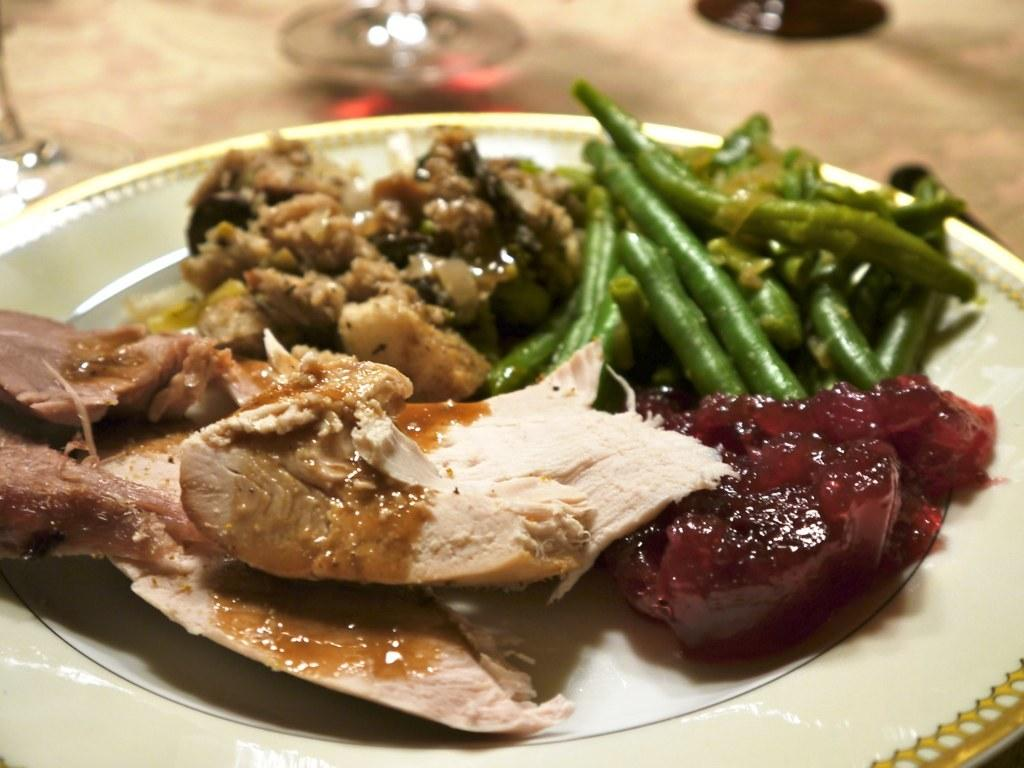What object is present on the plate in the image? There are food items on the plate in the image. What color is the plate? The plate is white in color. What other object is visible in the image besides the plate? There is a glass in the image. Can you describe the background of the image? The background of the image is blurred. What type of fish can be seen swimming in the jail in the image? There is no fish or jail present in the image; it features a plate with food items and a glass. 